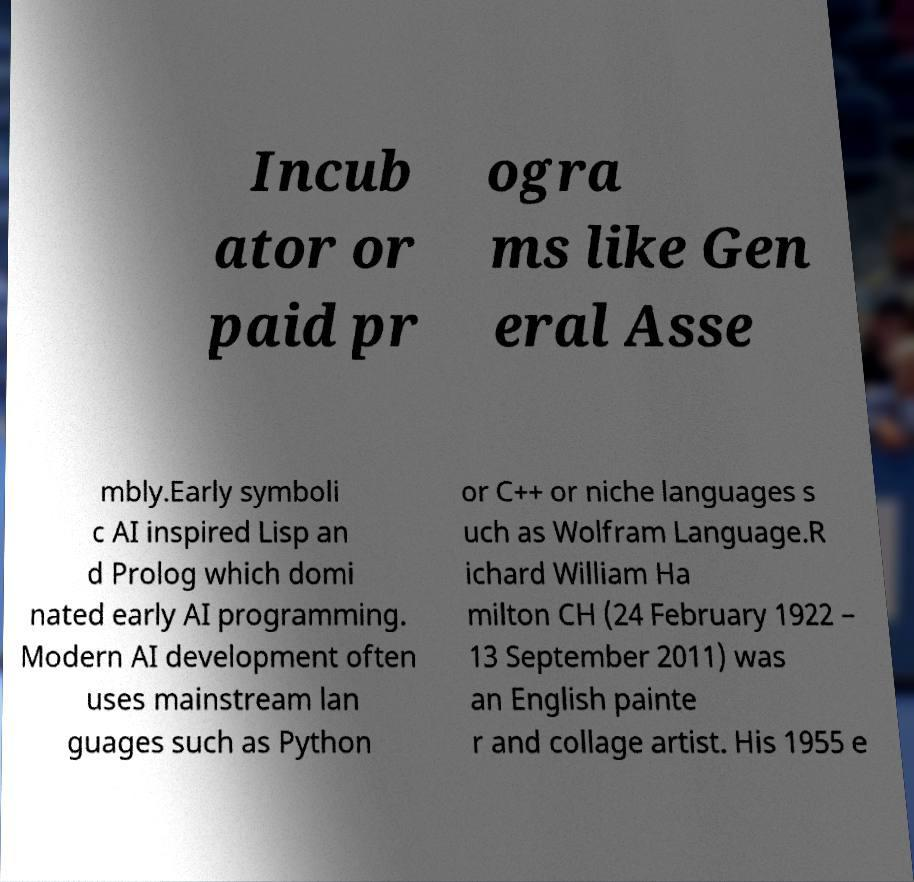Can you accurately transcribe the text from the provided image for me? Incub ator or paid pr ogra ms like Gen eral Asse mbly.Early symboli c AI inspired Lisp an d Prolog which domi nated early AI programming. Modern AI development often uses mainstream lan guages such as Python or C++ or niche languages s uch as Wolfram Language.R ichard William Ha milton CH (24 February 1922 – 13 September 2011) was an English painte r and collage artist. His 1955 e 